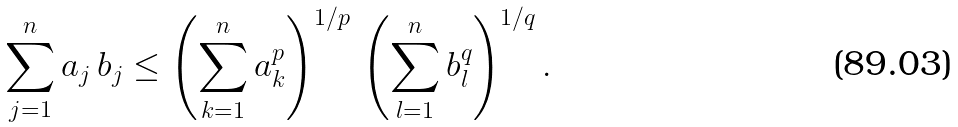Convert formula to latex. <formula><loc_0><loc_0><loc_500><loc_500>\sum _ { j = 1 } ^ { n } a _ { j } \, b _ { j } \leq \left ( \sum _ { k = 1 } ^ { n } a _ { k } ^ { p } \right ) ^ { 1 / p } \, \left ( \sum _ { l = 1 } ^ { n } b _ { l } ^ { q } \right ) ^ { 1 / q } .</formula> 